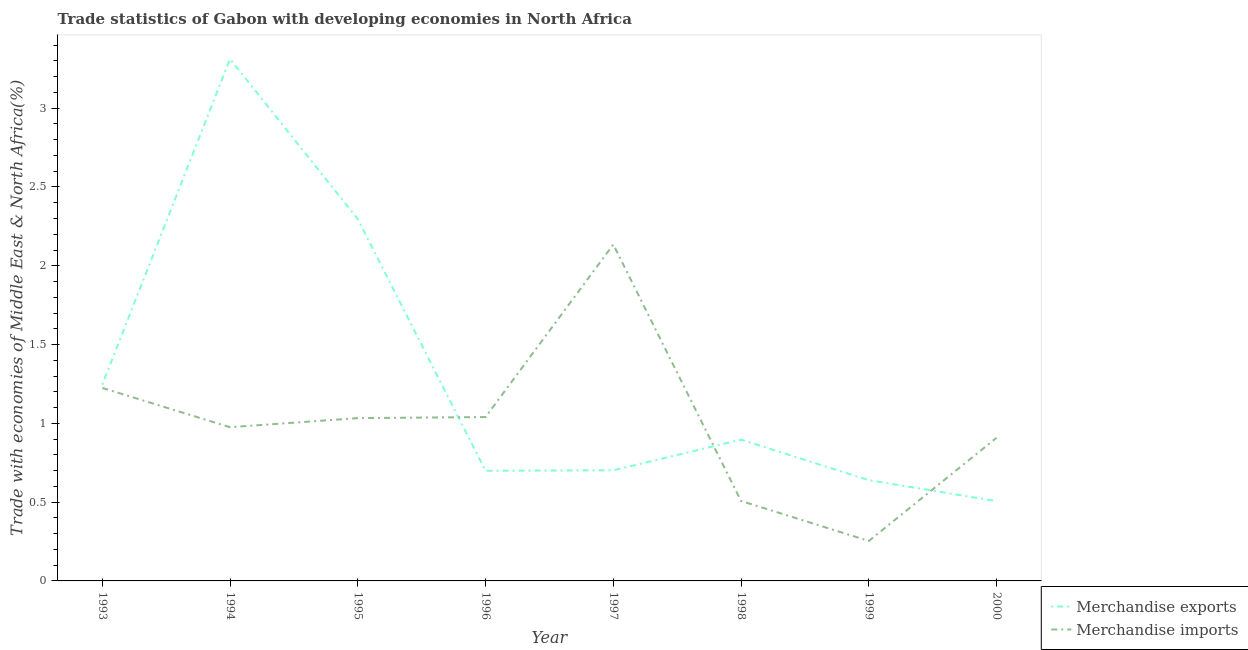Does the line corresponding to merchandise exports intersect with the line corresponding to merchandise imports?
Ensure brevity in your answer.  Yes. Is the number of lines equal to the number of legend labels?
Offer a very short reply. Yes. What is the merchandise imports in 2000?
Ensure brevity in your answer.  0.91. Across all years, what is the maximum merchandise exports?
Your response must be concise. 3.31. Across all years, what is the minimum merchandise imports?
Provide a succinct answer. 0.25. In which year was the merchandise exports maximum?
Your answer should be very brief. 1994. In which year was the merchandise exports minimum?
Make the answer very short. 2000. What is the total merchandise imports in the graph?
Ensure brevity in your answer.  8.08. What is the difference between the merchandise exports in 1997 and that in 1999?
Offer a terse response. 0.06. What is the difference between the merchandise exports in 1999 and the merchandise imports in 1997?
Keep it short and to the point. -1.5. What is the average merchandise exports per year?
Make the answer very short. 1.29. In the year 1999, what is the difference between the merchandise imports and merchandise exports?
Provide a succinct answer. -0.39. In how many years, is the merchandise exports greater than 2 %?
Your answer should be very brief. 2. What is the ratio of the merchandise imports in 1998 to that in 2000?
Keep it short and to the point. 0.56. What is the difference between the highest and the second highest merchandise exports?
Ensure brevity in your answer.  1.02. What is the difference between the highest and the lowest merchandise imports?
Keep it short and to the point. 1.88. Is the sum of the merchandise exports in 1994 and 1997 greater than the maximum merchandise imports across all years?
Offer a terse response. Yes. Does the merchandise imports monotonically increase over the years?
Offer a terse response. No. Is the merchandise exports strictly greater than the merchandise imports over the years?
Make the answer very short. No. Is the merchandise imports strictly less than the merchandise exports over the years?
Offer a very short reply. No. How many lines are there?
Your answer should be very brief. 2. How many years are there in the graph?
Provide a succinct answer. 8. Are the values on the major ticks of Y-axis written in scientific E-notation?
Ensure brevity in your answer.  No. Does the graph contain grids?
Offer a very short reply. No. What is the title of the graph?
Give a very brief answer. Trade statistics of Gabon with developing economies in North Africa. What is the label or title of the X-axis?
Offer a very short reply. Year. What is the label or title of the Y-axis?
Your response must be concise. Trade with economies of Middle East & North Africa(%). What is the Trade with economies of Middle East & North Africa(%) in Merchandise exports in 1993?
Offer a terse response. 1.25. What is the Trade with economies of Middle East & North Africa(%) in Merchandise imports in 1993?
Your answer should be very brief. 1.22. What is the Trade with economies of Middle East & North Africa(%) of Merchandise exports in 1994?
Your response must be concise. 3.31. What is the Trade with economies of Middle East & North Africa(%) in Merchandise imports in 1994?
Make the answer very short. 0.98. What is the Trade with economies of Middle East & North Africa(%) in Merchandise exports in 1995?
Provide a short and direct response. 2.3. What is the Trade with economies of Middle East & North Africa(%) of Merchandise imports in 1995?
Ensure brevity in your answer.  1.03. What is the Trade with economies of Middle East & North Africa(%) in Merchandise exports in 1996?
Provide a short and direct response. 0.7. What is the Trade with economies of Middle East & North Africa(%) in Merchandise imports in 1996?
Keep it short and to the point. 1.04. What is the Trade with economies of Middle East & North Africa(%) in Merchandise exports in 1997?
Provide a succinct answer. 0.7. What is the Trade with economies of Middle East & North Africa(%) in Merchandise imports in 1997?
Your response must be concise. 2.14. What is the Trade with economies of Middle East & North Africa(%) of Merchandise exports in 1998?
Your answer should be compact. 0.9. What is the Trade with economies of Middle East & North Africa(%) of Merchandise imports in 1998?
Offer a very short reply. 0.51. What is the Trade with economies of Middle East & North Africa(%) of Merchandise exports in 1999?
Your answer should be very brief. 0.64. What is the Trade with economies of Middle East & North Africa(%) in Merchandise imports in 1999?
Give a very brief answer. 0.25. What is the Trade with economies of Middle East & North Africa(%) in Merchandise exports in 2000?
Offer a very short reply. 0.51. What is the Trade with economies of Middle East & North Africa(%) in Merchandise imports in 2000?
Offer a very short reply. 0.91. Across all years, what is the maximum Trade with economies of Middle East & North Africa(%) of Merchandise exports?
Give a very brief answer. 3.31. Across all years, what is the maximum Trade with economies of Middle East & North Africa(%) of Merchandise imports?
Provide a succinct answer. 2.14. Across all years, what is the minimum Trade with economies of Middle East & North Africa(%) of Merchandise exports?
Your response must be concise. 0.51. Across all years, what is the minimum Trade with economies of Middle East & North Africa(%) of Merchandise imports?
Keep it short and to the point. 0.25. What is the total Trade with economies of Middle East & North Africa(%) of Merchandise exports in the graph?
Provide a short and direct response. 10.3. What is the total Trade with economies of Middle East & North Africa(%) of Merchandise imports in the graph?
Ensure brevity in your answer.  8.08. What is the difference between the Trade with economies of Middle East & North Africa(%) of Merchandise exports in 1993 and that in 1994?
Give a very brief answer. -2.07. What is the difference between the Trade with economies of Middle East & North Africa(%) of Merchandise imports in 1993 and that in 1994?
Offer a terse response. 0.25. What is the difference between the Trade with economies of Middle East & North Africa(%) of Merchandise exports in 1993 and that in 1995?
Give a very brief answer. -1.05. What is the difference between the Trade with economies of Middle East & North Africa(%) in Merchandise imports in 1993 and that in 1995?
Your answer should be compact. 0.19. What is the difference between the Trade with economies of Middle East & North Africa(%) of Merchandise exports in 1993 and that in 1996?
Provide a short and direct response. 0.55. What is the difference between the Trade with economies of Middle East & North Africa(%) in Merchandise imports in 1993 and that in 1996?
Offer a terse response. 0.18. What is the difference between the Trade with economies of Middle East & North Africa(%) in Merchandise exports in 1993 and that in 1997?
Make the answer very short. 0.54. What is the difference between the Trade with economies of Middle East & North Africa(%) of Merchandise imports in 1993 and that in 1997?
Offer a very short reply. -0.91. What is the difference between the Trade with economies of Middle East & North Africa(%) in Merchandise exports in 1993 and that in 1998?
Your response must be concise. 0.35. What is the difference between the Trade with economies of Middle East & North Africa(%) in Merchandise imports in 1993 and that in 1998?
Make the answer very short. 0.72. What is the difference between the Trade with economies of Middle East & North Africa(%) of Merchandise exports in 1993 and that in 1999?
Provide a short and direct response. 0.61. What is the difference between the Trade with economies of Middle East & North Africa(%) of Merchandise imports in 1993 and that in 1999?
Offer a very short reply. 0.97. What is the difference between the Trade with economies of Middle East & North Africa(%) of Merchandise exports in 1993 and that in 2000?
Offer a terse response. 0.74. What is the difference between the Trade with economies of Middle East & North Africa(%) in Merchandise imports in 1993 and that in 2000?
Give a very brief answer. 0.32. What is the difference between the Trade with economies of Middle East & North Africa(%) of Merchandise exports in 1994 and that in 1995?
Make the answer very short. 1.02. What is the difference between the Trade with economies of Middle East & North Africa(%) in Merchandise imports in 1994 and that in 1995?
Give a very brief answer. -0.06. What is the difference between the Trade with economies of Middle East & North Africa(%) of Merchandise exports in 1994 and that in 1996?
Provide a short and direct response. 2.61. What is the difference between the Trade with economies of Middle East & North Africa(%) of Merchandise imports in 1994 and that in 1996?
Your answer should be very brief. -0.06. What is the difference between the Trade with economies of Middle East & North Africa(%) in Merchandise exports in 1994 and that in 1997?
Ensure brevity in your answer.  2.61. What is the difference between the Trade with economies of Middle East & North Africa(%) in Merchandise imports in 1994 and that in 1997?
Offer a very short reply. -1.16. What is the difference between the Trade with economies of Middle East & North Africa(%) in Merchandise exports in 1994 and that in 1998?
Make the answer very short. 2.42. What is the difference between the Trade with economies of Middle East & North Africa(%) in Merchandise imports in 1994 and that in 1998?
Offer a terse response. 0.47. What is the difference between the Trade with economies of Middle East & North Africa(%) in Merchandise exports in 1994 and that in 1999?
Make the answer very short. 2.67. What is the difference between the Trade with economies of Middle East & North Africa(%) of Merchandise imports in 1994 and that in 1999?
Ensure brevity in your answer.  0.72. What is the difference between the Trade with economies of Middle East & North Africa(%) in Merchandise exports in 1994 and that in 2000?
Your answer should be compact. 2.81. What is the difference between the Trade with economies of Middle East & North Africa(%) of Merchandise imports in 1994 and that in 2000?
Offer a very short reply. 0.07. What is the difference between the Trade with economies of Middle East & North Africa(%) of Merchandise exports in 1995 and that in 1996?
Offer a terse response. 1.6. What is the difference between the Trade with economies of Middle East & North Africa(%) in Merchandise imports in 1995 and that in 1996?
Offer a very short reply. -0.01. What is the difference between the Trade with economies of Middle East & North Africa(%) in Merchandise exports in 1995 and that in 1997?
Give a very brief answer. 1.59. What is the difference between the Trade with economies of Middle East & North Africa(%) in Merchandise imports in 1995 and that in 1997?
Provide a succinct answer. -1.1. What is the difference between the Trade with economies of Middle East & North Africa(%) in Merchandise exports in 1995 and that in 1998?
Offer a very short reply. 1.4. What is the difference between the Trade with economies of Middle East & North Africa(%) in Merchandise imports in 1995 and that in 1998?
Your answer should be compact. 0.53. What is the difference between the Trade with economies of Middle East & North Africa(%) of Merchandise exports in 1995 and that in 1999?
Your answer should be compact. 1.66. What is the difference between the Trade with economies of Middle East & North Africa(%) in Merchandise imports in 1995 and that in 1999?
Ensure brevity in your answer.  0.78. What is the difference between the Trade with economies of Middle East & North Africa(%) in Merchandise exports in 1995 and that in 2000?
Offer a very short reply. 1.79. What is the difference between the Trade with economies of Middle East & North Africa(%) of Merchandise imports in 1995 and that in 2000?
Ensure brevity in your answer.  0.12. What is the difference between the Trade with economies of Middle East & North Africa(%) of Merchandise exports in 1996 and that in 1997?
Provide a succinct answer. -0. What is the difference between the Trade with economies of Middle East & North Africa(%) in Merchandise imports in 1996 and that in 1997?
Make the answer very short. -1.1. What is the difference between the Trade with economies of Middle East & North Africa(%) of Merchandise exports in 1996 and that in 1998?
Give a very brief answer. -0.2. What is the difference between the Trade with economies of Middle East & North Africa(%) of Merchandise imports in 1996 and that in 1998?
Give a very brief answer. 0.53. What is the difference between the Trade with economies of Middle East & North Africa(%) of Merchandise exports in 1996 and that in 1999?
Make the answer very short. 0.06. What is the difference between the Trade with economies of Middle East & North Africa(%) of Merchandise imports in 1996 and that in 1999?
Make the answer very short. 0.79. What is the difference between the Trade with economies of Middle East & North Africa(%) in Merchandise exports in 1996 and that in 2000?
Offer a terse response. 0.19. What is the difference between the Trade with economies of Middle East & North Africa(%) in Merchandise imports in 1996 and that in 2000?
Offer a very short reply. 0.13. What is the difference between the Trade with economies of Middle East & North Africa(%) in Merchandise exports in 1997 and that in 1998?
Offer a terse response. -0.19. What is the difference between the Trade with economies of Middle East & North Africa(%) in Merchandise imports in 1997 and that in 1998?
Offer a terse response. 1.63. What is the difference between the Trade with economies of Middle East & North Africa(%) in Merchandise exports in 1997 and that in 1999?
Your response must be concise. 0.06. What is the difference between the Trade with economies of Middle East & North Africa(%) of Merchandise imports in 1997 and that in 1999?
Provide a short and direct response. 1.88. What is the difference between the Trade with economies of Middle East & North Africa(%) of Merchandise exports in 1997 and that in 2000?
Make the answer very short. 0.2. What is the difference between the Trade with economies of Middle East & North Africa(%) in Merchandise imports in 1997 and that in 2000?
Provide a short and direct response. 1.23. What is the difference between the Trade with economies of Middle East & North Africa(%) of Merchandise exports in 1998 and that in 1999?
Provide a short and direct response. 0.26. What is the difference between the Trade with economies of Middle East & North Africa(%) of Merchandise imports in 1998 and that in 1999?
Provide a short and direct response. 0.25. What is the difference between the Trade with economies of Middle East & North Africa(%) of Merchandise exports in 1998 and that in 2000?
Give a very brief answer. 0.39. What is the difference between the Trade with economies of Middle East & North Africa(%) in Merchandise imports in 1998 and that in 2000?
Make the answer very short. -0.4. What is the difference between the Trade with economies of Middle East & North Africa(%) in Merchandise exports in 1999 and that in 2000?
Keep it short and to the point. 0.13. What is the difference between the Trade with economies of Middle East & North Africa(%) in Merchandise imports in 1999 and that in 2000?
Give a very brief answer. -0.65. What is the difference between the Trade with economies of Middle East & North Africa(%) of Merchandise exports in 1993 and the Trade with economies of Middle East & North Africa(%) of Merchandise imports in 1994?
Your answer should be very brief. 0.27. What is the difference between the Trade with economies of Middle East & North Africa(%) in Merchandise exports in 1993 and the Trade with economies of Middle East & North Africa(%) in Merchandise imports in 1995?
Offer a very short reply. 0.21. What is the difference between the Trade with economies of Middle East & North Africa(%) of Merchandise exports in 1993 and the Trade with economies of Middle East & North Africa(%) of Merchandise imports in 1996?
Provide a succinct answer. 0.21. What is the difference between the Trade with economies of Middle East & North Africa(%) of Merchandise exports in 1993 and the Trade with economies of Middle East & North Africa(%) of Merchandise imports in 1997?
Ensure brevity in your answer.  -0.89. What is the difference between the Trade with economies of Middle East & North Africa(%) in Merchandise exports in 1993 and the Trade with economies of Middle East & North Africa(%) in Merchandise imports in 1998?
Make the answer very short. 0.74. What is the difference between the Trade with economies of Middle East & North Africa(%) of Merchandise exports in 1993 and the Trade with economies of Middle East & North Africa(%) of Merchandise imports in 1999?
Keep it short and to the point. 0.99. What is the difference between the Trade with economies of Middle East & North Africa(%) in Merchandise exports in 1993 and the Trade with economies of Middle East & North Africa(%) in Merchandise imports in 2000?
Provide a succinct answer. 0.34. What is the difference between the Trade with economies of Middle East & North Africa(%) of Merchandise exports in 1994 and the Trade with economies of Middle East & North Africa(%) of Merchandise imports in 1995?
Your answer should be compact. 2.28. What is the difference between the Trade with economies of Middle East & North Africa(%) in Merchandise exports in 1994 and the Trade with economies of Middle East & North Africa(%) in Merchandise imports in 1996?
Keep it short and to the point. 2.27. What is the difference between the Trade with economies of Middle East & North Africa(%) of Merchandise exports in 1994 and the Trade with economies of Middle East & North Africa(%) of Merchandise imports in 1997?
Give a very brief answer. 1.18. What is the difference between the Trade with economies of Middle East & North Africa(%) of Merchandise exports in 1994 and the Trade with economies of Middle East & North Africa(%) of Merchandise imports in 1998?
Provide a short and direct response. 2.81. What is the difference between the Trade with economies of Middle East & North Africa(%) in Merchandise exports in 1994 and the Trade with economies of Middle East & North Africa(%) in Merchandise imports in 1999?
Offer a very short reply. 3.06. What is the difference between the Trade with economies of Middle East & North Africa(%) of Merchandise exports in 1994 and the Trade with economies of Middle East & North Africa(%) of Merchandise imports in 2000?
Make the answer very short. 2.4. What is the difference between the Trade with economies of Middle East & North Africa(%) of Merchandise exports in 1995 and the Trade with economies of Middle East & North Africa(%) of Merchandise imports in 1996?
Give a very brief answer. 1.26. What is the difference between the Trade with economies of Middle East & North Africa(%) in Merchandise exports in 1995 and the Trade with economies of Middle East & North Africa(%) in Merchandise imports in 1997?
Ensure brevity in your answer.  0.16. What is the difference between the Trade with economies of Middle East & North Africa(%) of Merchandise exports in 1995 and the Trade with economies of Middle East & North Africa(%) of Merchandise imports in 1998?
Your answer should be very brief. 1.79. What is the difference between the Trade with economies of Middle East & North Africa(%) of Merchandise exports in 1995 and the Trade with economies of Middle East & North Africa(%) of Merchandise imports in 1999?
Your answer should be very brief. 2.04. What is the difference between the Trade with economies of Middle East & North Africa(%) in Merchandise exports in 1995 and the Trade with economies of Middle East & North Africa(%) in Merchandise imports in 2000?
Provide a succinct answer. 1.39. What is the difference between the Trade with economies of Middle East & North Africa(%) of Merchandise exports in 1996 and the Trade with economies of Middle East & North Africa(%) of Merchandise imports in 1997?
Your answer should be very brief. -1.44. What is the difference between the Trade with economies of Middle East & North Africa(%) in Merchandise exports in 1996 and the Trade with economies of Middle East & North Africa(%) in Merchandise imports in 1998?
Provide a short and direct response. 0.19. What is the difference between the Trade with economies of Middle East & North Africa(%) of Merchandise exports in 1996 and the Trade with economies of Middle East & North Africa(%) of Merchandise imports in 1999?
Provide a short and direct response. 0.45. What is the difference between the Trade with economies of Middle East & North Africa(%) in Merchandise exports in 1996 and the Trade with economies of Middle East & North Africa(%) in Merchandise imports in 2000?
Make the answer very short. -0.21. What is the difference between the Trade with economies of Middle East & North Africa(%) in Merchandise exports in 1997 and the Trade with economies of Middle East & North Africa(%) in Merchandise imports in 1998?
Offer a terse response. 0.19. What is the difference between the Trade with economies of Middle East & North Africa(%) of Merchandise exports in 1997 and the Trade with economies of Middle East & North Africa(%) of Merchandise imports in 1999?
Your response must be concise. 0.45. What is the difference between the Trade with economies of Middle East & North Africa(%) of Merchandise exports in 1997 and the Trade with economies of Middle East & North Africa(%) of Merchandise imports in 2000?
Keep it short and to the point. -0.21. What is the difference between the Trade with economies of Middle East & North Africa(%) of Merchandise exports in 1998 and the Trade with economies of Middle East & North Africa(%) of Merchandise imports in 1999?
Give a very brief answer. 0.64. What is the difference between the Trade with economies of Middle East & North Africa(%) in Merchandise exports in 1998 and the Trade with economies of Middle East & North Africa(%) in Merchandise imports in 2000?
Make the answer very short. -0.01. What is the difference between the Trade with economies of Middle East & North Africa(%) in Merchandise exports in 1999 and the Trade with economies of Middle East & North Africa(%) in Merchandise imports in 2000?
Your response must be concise. -0.27. What is the average Trade with economies of Middle East & North Africa(%) in Merchandise exports per year?
Make the answer very short. 1.29. What is the average Trade with economies of Middle East & North Africa(%) in Merchandise imports per year?
Make the answer very short. 1.01. In the year 1993, what is the difference between the Trade with economies of Middle East & North Africa(%) of Merchandise exports and Trade with economies of Middle East & North Africa(%) of Merchandise imports?
Your answer should be very brief. 0.02. In the year 1994, what is the difference between the Trade with economies of Middle East & North Africa(%) in Merchandise exports and Trade with economies of Middle East & North Africa(%) in Merchandise imports?
Offer a terse response. 2.34. In the year 1995, what is the difference between the Trade with economies of Middle East & North Africa(%) in Merchandise exports and Trade with economies of Middle East & North Africa(%) in Merchandise imports?
Your response must be concise. 1.26. In the year 1996, what is the difference between the Trade with economies of Middle East & North Africa(%) of Merchandise exports and Trade with economies of Middle East & North Africa(%) of Merchandise imports?
Provide a short and direct response. -0.34. In the year 1997, what is the difference between the Trade with economies of Middle East & North Africa(%) of Merchandise exports and Trade with economies of Middle East & North Africa(%) of Merchandise imports?
Offer a terse response. -1.43. In the year 1998, what is the difference between the Trade with economies of Middle East & North Africa(%) of Merchandise exports and Trade with economies of Middle East & North Africa(%) of Merchandise imports?
Provide a succinct answer. 0.39. In the year 1999, what is the difference between the Trade with economies of Middle East & North Africa(%) in Merchandise exports and Trade with economies of Middle East & North Africa(%) in Merchandise imports?
Make the answer very short. 0.39. In the year 2000, what is the difference between the Trade with economies of Middle East & North Africa(%) of Merchandise exports and Trade with economies of Middle East & North Africa(%) of Merchandise imports?
Provide a short and direct response. -0.4. What is the ratio of the Trade with economies of Middle East & North Africa(%) of Merchandise exports in 1993 to that in 1994?
Keep it short and to the point. 0.38. What is the ratio of the Trade with economies of Middle East & North Africa(%) of Merchandise imports in 1993 to that in 1994?
Provide a short and direct response. 1.26. What is the ratio of the Trade with economies of Middle East & North Africa(%) of Merchandise exports in 1993 to that in 1995?
Provide a short and direct response. 0.54. What is the ratio of the Trade with economies of Middle East & North Africa(%) of Merchandise imports in 1993 to that in 1995?
Provide a short and direct response. 1.19. What is the ratio of the Trade with economies of Middle East & North Africa(%) of Merchandise exports in 1993 to that in 1996?
Make the answer very short. 1.78. What is the ratio of the Trade with economies of Middle East & North Africa(%) in Merchandise imports in 1993 to that in 1996?
Provide a short and direct response. 1.18. What is the ratio of the Trade with economies of Middle East & North Africa(%) of Merchandise exports in 1993 to that in 1997?
Make the answer very short. 1.77. What is the ratio of the Trade with economies of Middle East & North Africa(%) in Merchandise imports in 1993 to that in 1997?
Your response must be concise. 0.57. What is the ratio of the Trade with economies of Middle East & North Africa(%) in Merchandise exports in 1993 to that in 1998?
Keep it short and to the point. 1.39. What is the ratio of the Trade with economies of Middle East & North Africa(%) in Merchandise imports in 1993 to that in 1998?
Give a very brief answer. 2.41. What is the ratio of the Trade with economies of Middle East & North Africa(%) of Merchandise exports in 1993 to that in 1999?
Provide a succinct answer. 1.95. What is the ratio of the Trade with economies of Middle East & North Africa(%) of Merchandise imports in 1993 to that in 1999?
Give a very brief answer. 4.83. What is the ratio of the Trade with economies of Middle East & North Africa(%) in Merchandise exports in 1993 to that in 2000?
Ensure brevity in your answer.  2.46. What is the ratio of the Trade with economies of Middle East & North Africa(%) of Merchandise imports in 1993 to that in 2000?
Provide a succinct answer. 1.35. What is the ratio of the Trade with economies of Middle East & North Africa(%) of Merchandise exports in 1994 to that in 1995?
Offer a very short reply. 1.44. What is the ratio of the Trade with economies of Middle East & North Africa(%) in Merchandise imports in 1994 to that in 1995?
Make the answer very short. 0.94. What is the ratio of the Trade with economies of Middle East & North Africa(%) of Merchandise exports in 1994 to that in 1996?
Offer a terse response. 4.74. What is the ratio of the Trade with economies of Middle East & North Africa(%) in Merchandise imports in 1994 to that in 1996?
Offer a terse response. 0.94. What is the ratio of the Trade with economies of Middle East & North Africa(%) in Merchandise exports in 1994 to that in 1997?
Your answer should be very brief. 4.72. What is the ratio of the Trade with economies of Middle East & North Africa(%) in Merchandise imports in 1994 to that in 1997?
Keep it short and to the point. 0.46. What is the ratio of the Trade with economies of Middle East & North Africa(%) of Merchandise exports in 1994 to that in 1998?
Ensure brevity in your answer.  3.69. What is the ratio of the Trade with economies of Middle East & North Africa(%) of Merchandise imports in 1994 to that in 1998?
Give a very brief answer. 1.92. What is the ratio of the Trade with economies of Middle East & North Africa(%) of Merchandise exports in 1994 to that in 1999?
Ensure brevity in your answer.  5.18. What is the ratio of the Trade with economies of Middle East & North Africa(%) of Merchandise imports in 1994 to that in 1999?
Provide a succinct answer. 3.84. What is the ratio of the Trade with economies of Middle East & North Africa(%) of Merchandise exports in 1994 to that in 2000?
Offer a terse response. 6.54. What is the ratio of the Trade with economies of Middle East & North Africa(%) in Merchandise imports in 1994 to that in 2000?
Offer a very short reply. 1.07. What is the ratio of the Trade with economies of Middle East & North Africa(%) of Merchandise exports in 1995 to that in 1996?
Your answer should be very brief. 3.29. What is the ratio of the Trade with economies of Middle East & North Africa(%) in Merchandise exports in 1995 to that in 1997?
Provide a short and direct response. 3.27. What is the ratio of the Trade with economies of Middle East & North Africa(%) in Merchandise imports in 1995 to that in 1997?
Keep it short and to the point. 0.48. What is the ratio of the Trade with economies of Middle East & North Africa(%) of Merchandise exports in 1995 to that in 1998?
Provide a succinct answer. 2.56. What is the ratio of the Trade with economies of Middle East & North Africa(%) of Merchandise imports in 1995 to that in 1998?
Your answer should be compact. 2.04. What is the ratio of the Trade with economies of Middle East & North Africa(%) of Merchandise exports in 1995 to that in 1999?
Keep it short and to the point. 3.59. What is the ratio of the Trade with economies of Middle East & North Africa(%) of Merchandise imports in 1995 to that in 1999?
Make the answer very short. 4.07. What is the ratio of the Trade with economies of Middle East & North Africa(%) of Merchandise exports in 1995 to that in 2000?
Provide a succinct answer. 4.53. What is the ratio of the Trade with economies of Middle East & North Africa(%) in Merchandise imports in 1995 to that in 2000?
Give a very brief answer. 1.14. What is the ratio of the Trade with economies of Middle East & North Africa(%) of Merchandise exports in 1996 to that in 1997?
Offer a terse response. 1. What is the ratio of the Trade with economies of Middle East & North Africa(%) of Merchandise imports in 1996 to that in 1997?
Ensure brevity in your answer.  0.49. What is the ratio of the Trade with economies of Middle East & North Africa(%) of Merchandise exports in 1996 to that in 1998?
Ensure brevity in your answer.  0.78. What is the ratio of the Trade with economies of Middle East & North Africa(%) of Merchandise imports in 1996 to that in 1998?
Your response must be concise. 2.05. What is the ratio of the Trade with economies of Middle East & North Africa(%) of Merchandise exports in 1996 to that in 1999?
Offer a very short reply. 1.09. What is the ratio of the Trade with economies of Middle East & North Africa(%) in Merchandise imports in 1996 to that in 1999?
Provide a short and direct response. 4.1. What is the ratio of the Trade with economies of Middle East & North Africa(%) of Merchandise exports in 1996 to that in 2000?
Keep it short and to the point. 1.38. What is the ratio of the Trade with economies of Middle East & North Africa(%) in Merchandise imports in 1996 to that in 2000?
Your answer should be very brief. 1.14. What is the ratio of the Trade with economies of Middle East & North Africa(%) in Merchandise exports in 1997 to that in 1998?
Keep it short and to the point. 0.78. What is the ratio of the Trade with economies of Middle East & North Africa(%) of Merchandise imports in 1997 to that in 1998?
Give a very brief answer. 4.21. What is the ratio of the Trade with economies of Middle East & North Africa(%) of Merchandise exports in 1997 to that in 1999?
Offer a very short reply. 1.1. What is the ratio of the Trade with economies of Middle East & North Africa(%) of Merchandise imports in 1997 to that in 1999?
Offer a very short reply. 8.41. What is the ratio of the Trade with economies of Middle East & North Africa(%) of Merchandise exports in 1997 to that in 2000?
Give a very brief answer. 1.39. What is the ratio of the Trade with economies of Middle East & North Africa(%) of Merchandise imports in 1997 to that in 2000?
Offer a very short reply. 2.35. What is the ratio of the Trade with economies of Middle East & North Africa(%) of Merchandise exports in 1998 to that in 1999?
Your response must be concise. 1.4. What is the ratio of the Trade with economies of Middle East & North Africa(%) in Merchandise imports in 1998 to that in 1999?
Offer a terse response. 2. What is the ratio of the Trade with economies of Middle East & North Africa(%) of Merchandise exports in 1998 to that in 2000?
Provide a succinct answer. 1.77. What is the ratio of the Trade with economies of Middle East & North Africa(%) of Merchandise imports in 1998 to that in 2000?
Keep it short and to the point. 0.56. What is the ratio of the Trade with economies of Middle East & North Africa(%) of Merchandise exports in 1999 to that in 2000?
Give a very brief answer. 1.26. What is the ratio of the Trade with economies of Middle East & North Africa(%) of Merchandise imports in 1999 to that in 2000?
Provide a short and direct response. 0.28. What is the difference between the highest and the second highest Trade with economies of Middle East & North Africa(%) of Merchandise exports?
Give a very brief answer. 1.02. What is the difference between the highest and the second highest Trade with economies of Middle East & North Africa(%) in Merchandise imports?
Offer a very short reply. 0.91. What is the difference between the highest and the lowest Trade with economies of Middle East & North Africa(%) in Merchandise exports?
Your answer should be compact. 2.81. What is the difference between the highest and the lowest Trade with economies of Middle East & North Africa(%) of Merchandise imports?
Give a very brief answer. 1.88. 